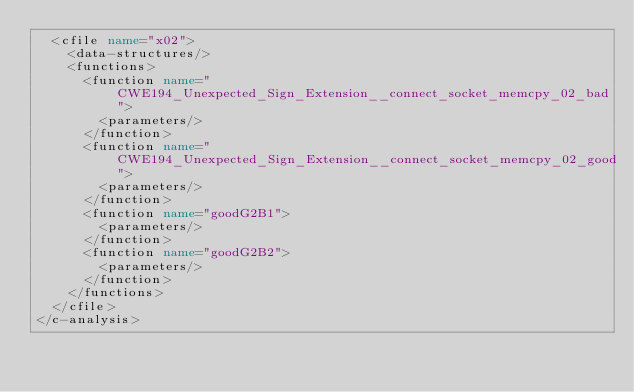<code> <loc_0><loc_0><loc_500><loc_500><_XML_>  <cfile name="x02">
    <data-structures/>
    <functions>
      <function name="CWE194_Unexpected_Sign_Extension__connect_socket_memcpy_02_bad">
        <parameters/>
      </function>
      <function name="CWE194_Unexpected_Sign_Extension__connect_socket_memcpy_02_good">
        <parameters/>
      </function>
      <function name="goodG2B1">
        <parameters/>
      </function>
      <function name="goodG2B2">
        <parameters/>
      </function>
    </functions>
  </cfile>
</c-analysis>
</code> 